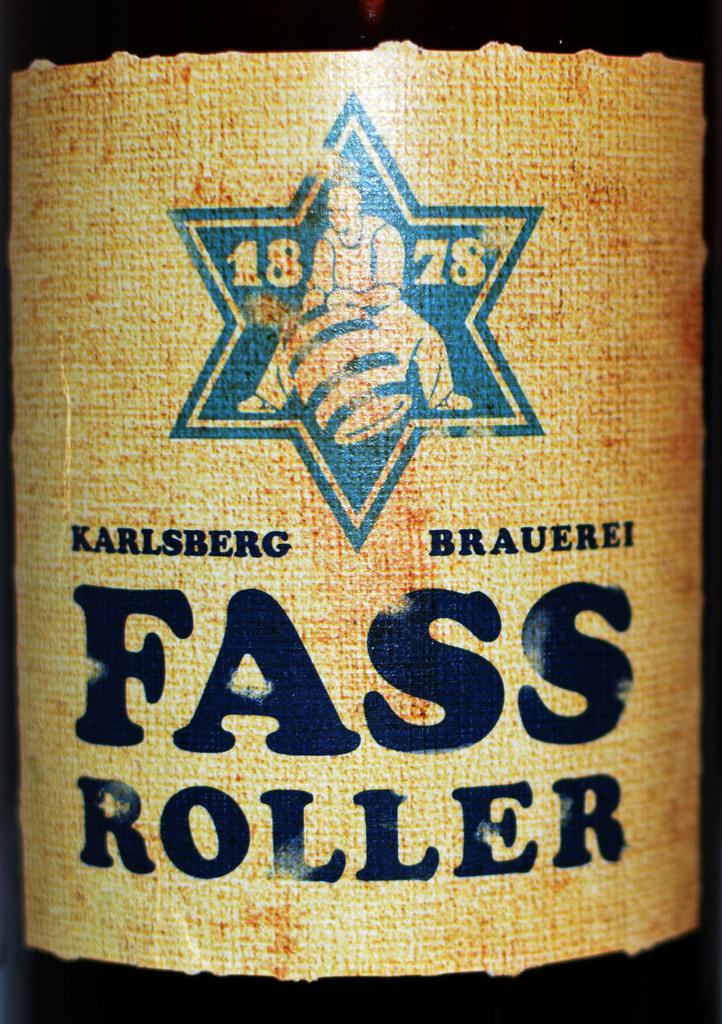<image>
Write a terse but informative summary of the picture. a label that says '1878 karlsberg brauerei fass roller' 